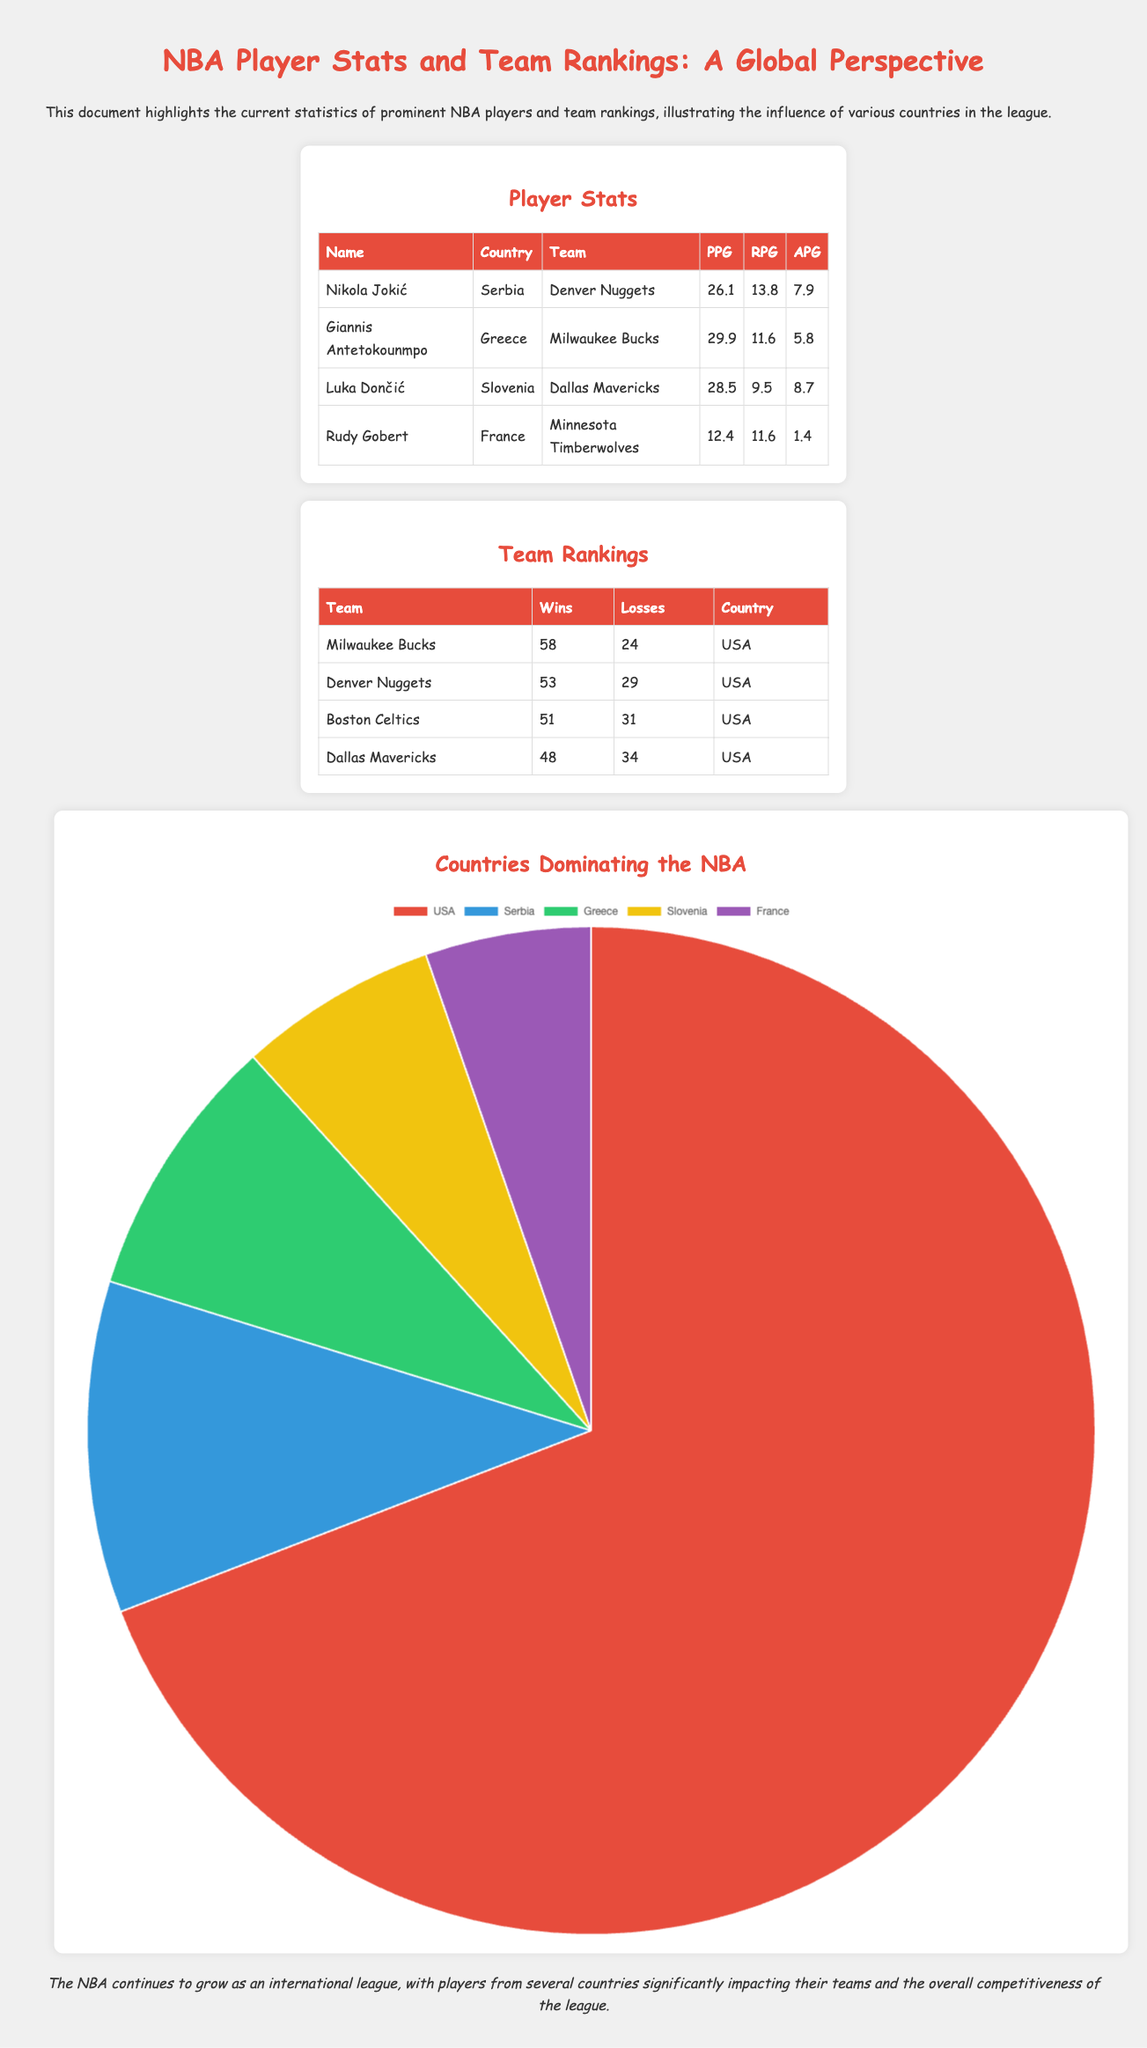What is Giannis Antetokounmpo's points per game? Giannis Antetokounmpo's points per game, as shown in the player stats table, is 29.9.
Answer: 29.9 Which team has the most wins? The team with the most wins, according to the team rankings table, is the Milwaukee Bucks with 58 wins.
Answer: Milwaukee Bucks How many players are listed in the player stats section? There are four players listed in the player stats section of the document.
Answer: 4 What percentage of players in the NBA are from the USA? The pie chart indicates that 65% of players in the NBA are from the USA.
Answer: 65% Who plays for the Dallas Mavericks? Luka Dončić is the player listed in the document who plays for the Dallas Mavericks.
Answer: Luka Dončić Which country has the least representation in the league according to the chart? The country with the least representation according to the pie chart is France, with 5%.
Answer: France What does the document highlight about the NBA? The document highlights the current statistics and influence of various countries in the league.
Answer: Influence of various countries How many rebounds per game does Rudy Gobert average? Rudy Gobert averages 11.6 rebounds per game, as indicated in the player stats table.
Answer: 11.6 What is the background color of the chart representing countries in the NBA? The chart representing countries in the NBA has a background color of white, as shown in the style.
Answer: White 